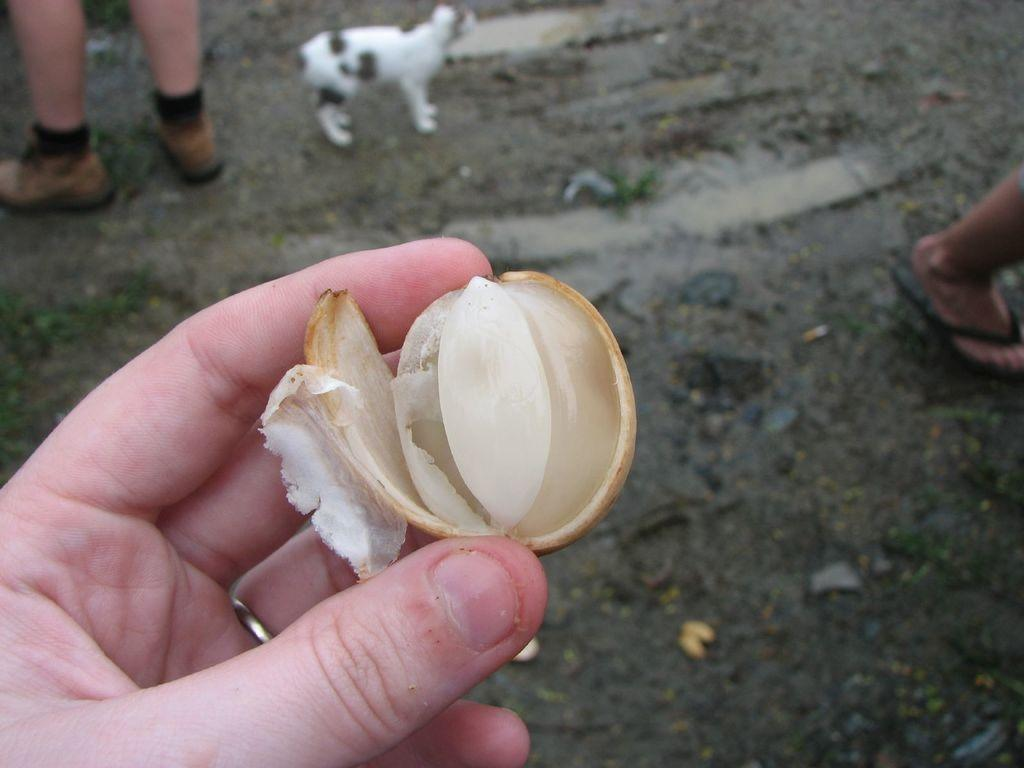What is the person holding in the image? There is a person's hand holding an onion in the image. What other body part of the person can be seen in the image? A person's leg is visible at the top of the image. What type of animal is present in the image? There is a white-colored dog in the image. Are there any other people visible in the image? Yes, another person's leg is visible on the right side of the image. What type of brush is the person using to teach the dog in the image? There is no brush or teaching activity present in the image; it only shows a person holding an onion, a dog, and two legs. 